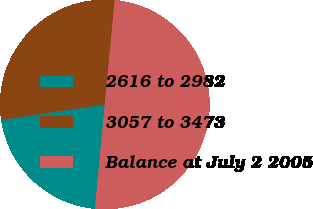Convert chart. <chart><loc_0><loc_0><loc_500><loc_500><pie_chart><fcel>2616 to 2982<fcel>3057 to 3473<fcel>Balance at July 2 2005<nl><fcel>21.14%<fcel>28.86%<fcel>50.0%<nl></chart> 